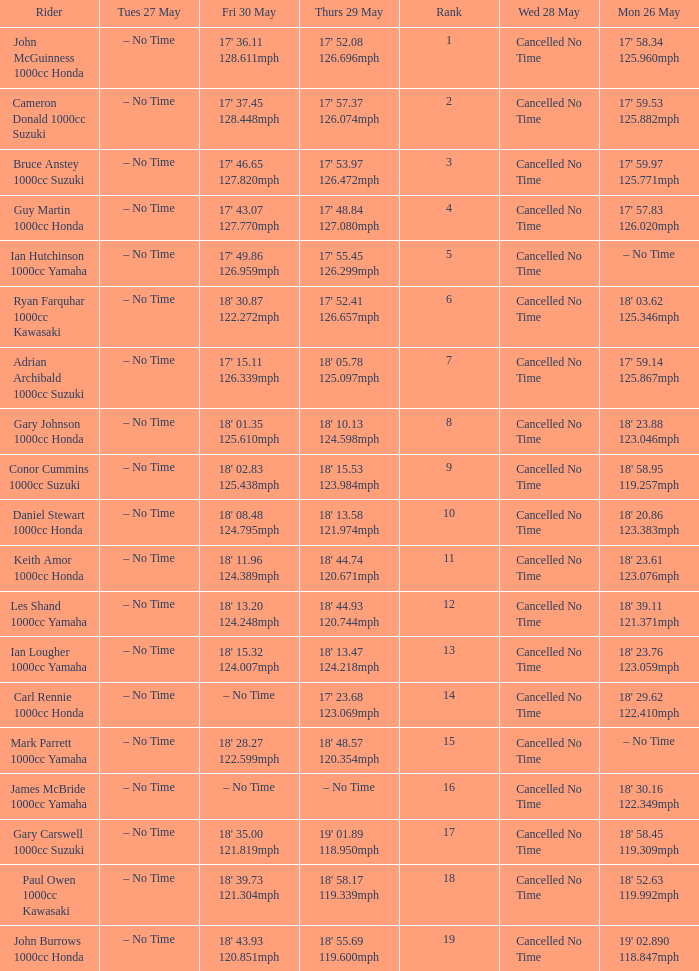Help me parse the entirety of this table. {'header': ['Rider', 'Tues 27 May', 'Fri 30 May', 'Thurs 29 May', 'Rank', 'Wed 28 May', 'Mon 26 May'], 'rows': [['John McGuinness 1000cc Honda', '– No Time', "17' 36.11 128.611mph", "17' 52.08 126.696mph", '1', 'Cancelled No Time', "17' 58.34 125.960mph"], ['Cameron Donald 1000cc Suzuki', '– No Time', "17' 37.45 128.448mph", "17' 57.37 126.074mph", '2', 'Cancelled No Time', "17' 59.53 125.882mph"], ['Bruce Anstey 1000cc Suzuki', '– No Time', "17' 46.65 127.820mph", "17' 53.97 126.472mph", '3', 'Cancelled No Time', "17' 59.97 125.771mph"], ['Guy Martin 1000cc Honda', '– No Time', "17' 43.07 127.770mph", "17' 48.84 127.080mph", '4', 'Cancelled No Time', "17' 57.83 126.020mph"], ['Ian Hutchinson 1000cc Yamaha', '– No Time', "17' 49.86 126.959mph", "17' 55.45 126.299mph", '5', 'Cancelled No Time', '– No Time'], ['Ryan Farquhar 1000cc Kawasaki', '– No Time', "18' 30.87 122.272mph", "17' 52.41 126.657mph", '6', 'Cancelled No Time', "18' 03.62 125.346mph"], ['Adrian Archibald 1000cc Suzuki', '– No Time', "17' 15.11 126.339mph", "18' 05.78 125.097mph", '7', 'Cancelled No Time', "17' 59.14 125.867mph"], ['Gary Johnson 1000cc Honda', '– No Time', "18' 01.35 125.610mph", "18' 10.13 124.598mph", '8', 'Cancelled No Time', "18' 23.88 123.046mph"], ['Conor Cummins 1000cc Suzuki', '– No Time', "18' 02.83 125.438mph", "18' 15.53 123.984mph", '9', 'Cancelled No Time', "18' 58.95 119.257mph"], ['Daniel Stewart 1000cc Honda', '– No Time', "18' 08.48 124.795mph", "18' 13.58 121.974mph", '10', 'Cancelled No Time', "18' 20.86 123.383mph"], ['Keith Amor 1000cc Honda', '– No Time', "18' 11.96 124.389mph", "18' 44.74 120.671mph", '11', 'Cancelled No Time', "18' 23.61 123.076mph"], ['Les Shand 1000cc Yamaha', '– No Time', "18' 13.20 124.248mph", "18' 44.93 120.744mph", '12', 'Cancelled No Time', "18' 39.11 121.371mph"], ['Ian Lougher 1000cc Yamaha', '– No Time', "18' 15.32 124.007mph", "18' 13.47 124.218mph", '13', 'Cancelled No Time', "18' 23.76 123.059mph"], ['Carl Rennie 1000cc Honda', '– No Time', '– No Time', "17' 23.68 123.069mph", '14', 'Cancelled No Time', "18' 29.62 122.410mph"], ['Mark Parrett 1000cc Yamaha', '– No Time', "18' 28.27 122.599mph", "18' 48.57 120.354mph", '15', 'Cancelled No Time', '– No Time'], ['James McBride 1000cc Yamaha', '– No Time', '– No Time', '– No Time', '16', 'Cancelled No Time', "18' 30.16 122.349mph"], ['Gary Carswell 1000cc Suzuki', '– No Time', "18' 35.00 121.819mph", "19' 01.89 118.950mph", '17', 'Cancelled No Time', "18' 58.45 119.309mph"], ['Paul Owen 1000cc Kawasaki', '– No Time', "18' 39.73 121.304mph", "18' 58.17 119.339mph", '18', 'Cancelled No Time', "18' 52.63 119.992mph"], ['John Burrows 1000cc Honda', '– No Time', "18' 43.93 120.851mph", "18' 55.69 119.600mph", '19', 'Cancelled No Time', "19' 02.890 118.847mph"]]} What tims is wed may 28 and mon may 26 is 17' 58.34 125.960mph? Cancelled No Time. 